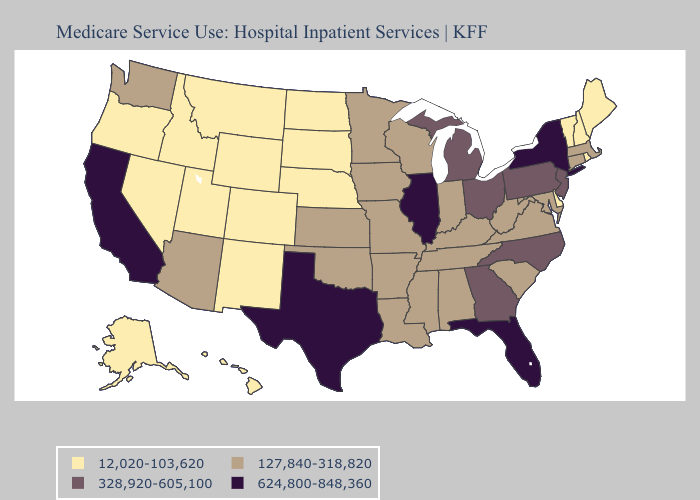What is the highest value in states that border Alabama?
Be succinct. 624,800-848,360. Does West Virginia have the highest value in the USA?
Short answer required. No. Among the states that border Nebraska , which have the highest value?
Short answer required. Iowa, Kansas, Missouri. Which states hav the highest value in the South?
Concise answer only. Florida, Texas. What is the lowest value in the MidWest?
Short answer required. 12,020-103,620. Does New Hampshire have the highest value in the Northeast?
Be succinct. No. Among the states that border Virginia , which have the highest value?
Write a very short answer. North Carolina. Does the first symbol in the legend represent the smallest category?
Concise answer only. Yes. Which states have the lowest value in the USA?
Short answer required. Alaska, Colorado, Delaware, Hawaii, Idaho, Maine, Montana, Nebraska, Nevada, New Hampshire, New Mexico, North Dakota, Oregon, Rhode Island, South Dakota, Utah, Vermont, Wyoming. Does Illinois have the highest value in the MidWest?
Be succinct. Yes. Among the states that border Arkansas , which have the highest value?
Quick response, please. Texas. What is the lowest value in the USA?
Concise answer only. 12,020-103,620. Does Rhode Island have the highest value in the Northeast?
Concise answer only. No. Does Illinois have the highest value in the MidWest?
Write a very short answer. Yes. 